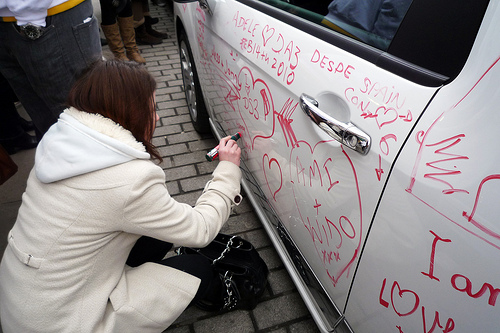<image>
Is there a door handle above the woman? Yes. The door handle is positioned above the woman in the vertical space, higher up in the scene. 